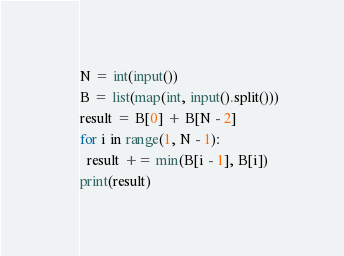Convert code to text. <code><loc_0><loc_0><loc_500><loc_500><_Python_>N = int(input())
B = list(map(int, input().split()))
result = B[0] + B[N - 2]
for i in range(1, N - 1):
  result += min(B[i - 1], B[i])
print(result)
</code> 